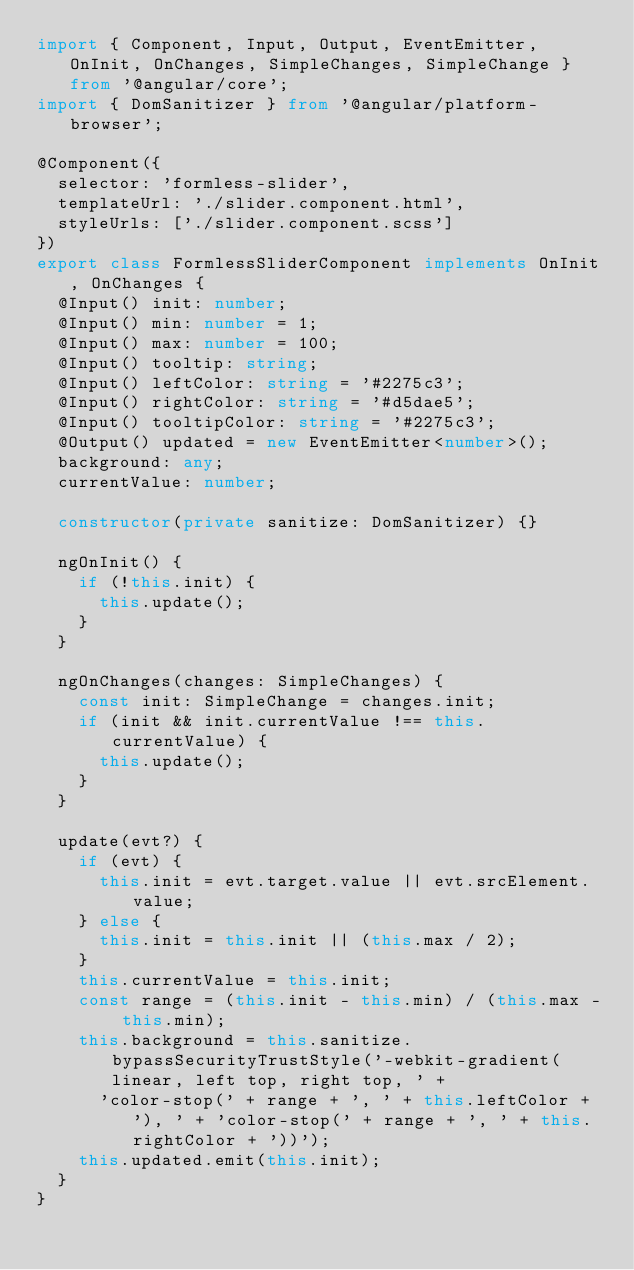Convert code to text. <code><loc_0><loc_0><loc_500><loc_500><_TypeScript_>import { Component, Input, Output, EventEmitter, OnInit, OnChanges, SimpleChanges, SimpleChange } from '@angular/core';
import { DomSanitizer } from '@angular/platform-browser';

@Component({
  selector: 'formless-slider',
  templateUrl: './slider.component.html',
  styleUrls: ['./slider.component.scss']
})
export class FormlessSliderComponent implements OnInit, OnChanges {
  @Input() init: number;
  @Input() min: number = 1;
  @Input() max: number = 100;
  @Input() tooltip: string;
  @Input() leftColor: string = '#2275c3';
  @Input() rightColor: string = '#d5dae5';
  @Input() tooltipColor: string = '#2275c3';
  @Output() updated = new EventEmitter<number>();
  background: any;
  currentValue: number;

  constructor(private sanitize: DomSanitizer) {}

  ngOnInit() {
    if (!this.init) {
      this.update();
    }
  }

  ngOnChanges(changes: SimpleChanges) {
    const init: SimpleChange = changes.init;
    if (init && init.currentValue !== this.currentValue) {
      this.update();
    }
  }

  update(evt?) {
    if (evt) {
      this.init = evt.target.value || evt.srcElement.value;
    } else {
      this.init = this.init || (this.max / 2);
    }
    this.currentValue = this.init;
    const range = (this.init - this.min) / (this.max - this.min);
    this.background = this.sanitize.bypassSecurityTrustStyle('-webkit-gradient(linear, left top, right top, ' +
      'color-stop(' + range + ', ' + this.leftColor + '), ' + 'color-stop(' + range + ', ' + this.rightColor + '))');
    this.updated.emit(this.init);
  }
}
</code> 